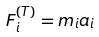Convert formula to latex. <formula><loc_0><loc_0><loc_500><loc_500>F _ { i } ^ { ( T ) } = m _ { i } a _ { i }</formula> 